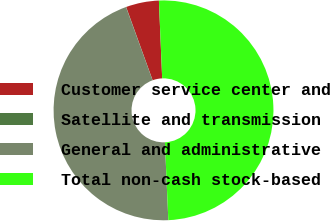<chart> <loc_0><loc_0><loc_500><loc_500><pie_chart><fcel>Customer service center and<fcel>Satellite and transmission<fcel>General and administrative<fcel>Total non-cash stock-based<nl><fcel>4.85%<fcel>0.03%<fcel>45.15%<fcel>49.97%<nl></chart> 